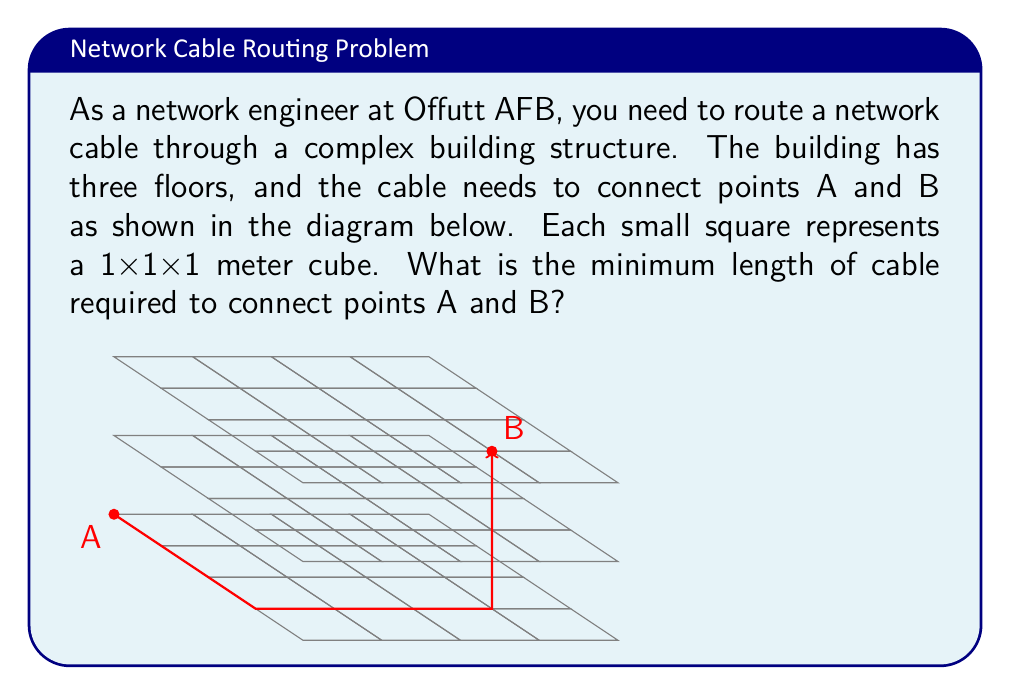Give your solution to this math problem. To solve this problem, we need to find the shortest path between points A and B. In a 3D space, the shortest path is not always a straight line due to obstacles. Let's break down the problem step-by-step:

1) First, let's identify the coordinates of points A and B:
   A: (0, 0, 0)
   B: (3, 3, 2)

2) The cable needs to follow the edges of the cubes. We can break down the path into three segments:
   - Moving along the x-axis
   - Moving along the y-axis
   - Moving along the z-axis

3) The optimal path will minimize the total distance. In this case:
   - Move 3 units along the x-axis: (0,0,0) to (3,0,0)
   - Move 3 units along the y-axis: (3,0,0) to (3,3,0)
   - Move 2 units along the z-axis: (3,3,0) to (3,3,2)

4) Calculate the total length:
   $$\text{Total length} = 3 + 3 + 2 = 8\text{ meters}$$

5) We can verify this is the shortest path because:
   - Any other path would require the same number of moves along each axis.
   - There's no diagonal path that could be shorter given the constraints of following cube edges.

Therefore, the minimum length of cable required to connect points A and B is 8 meters.
Answer: 8 meters 